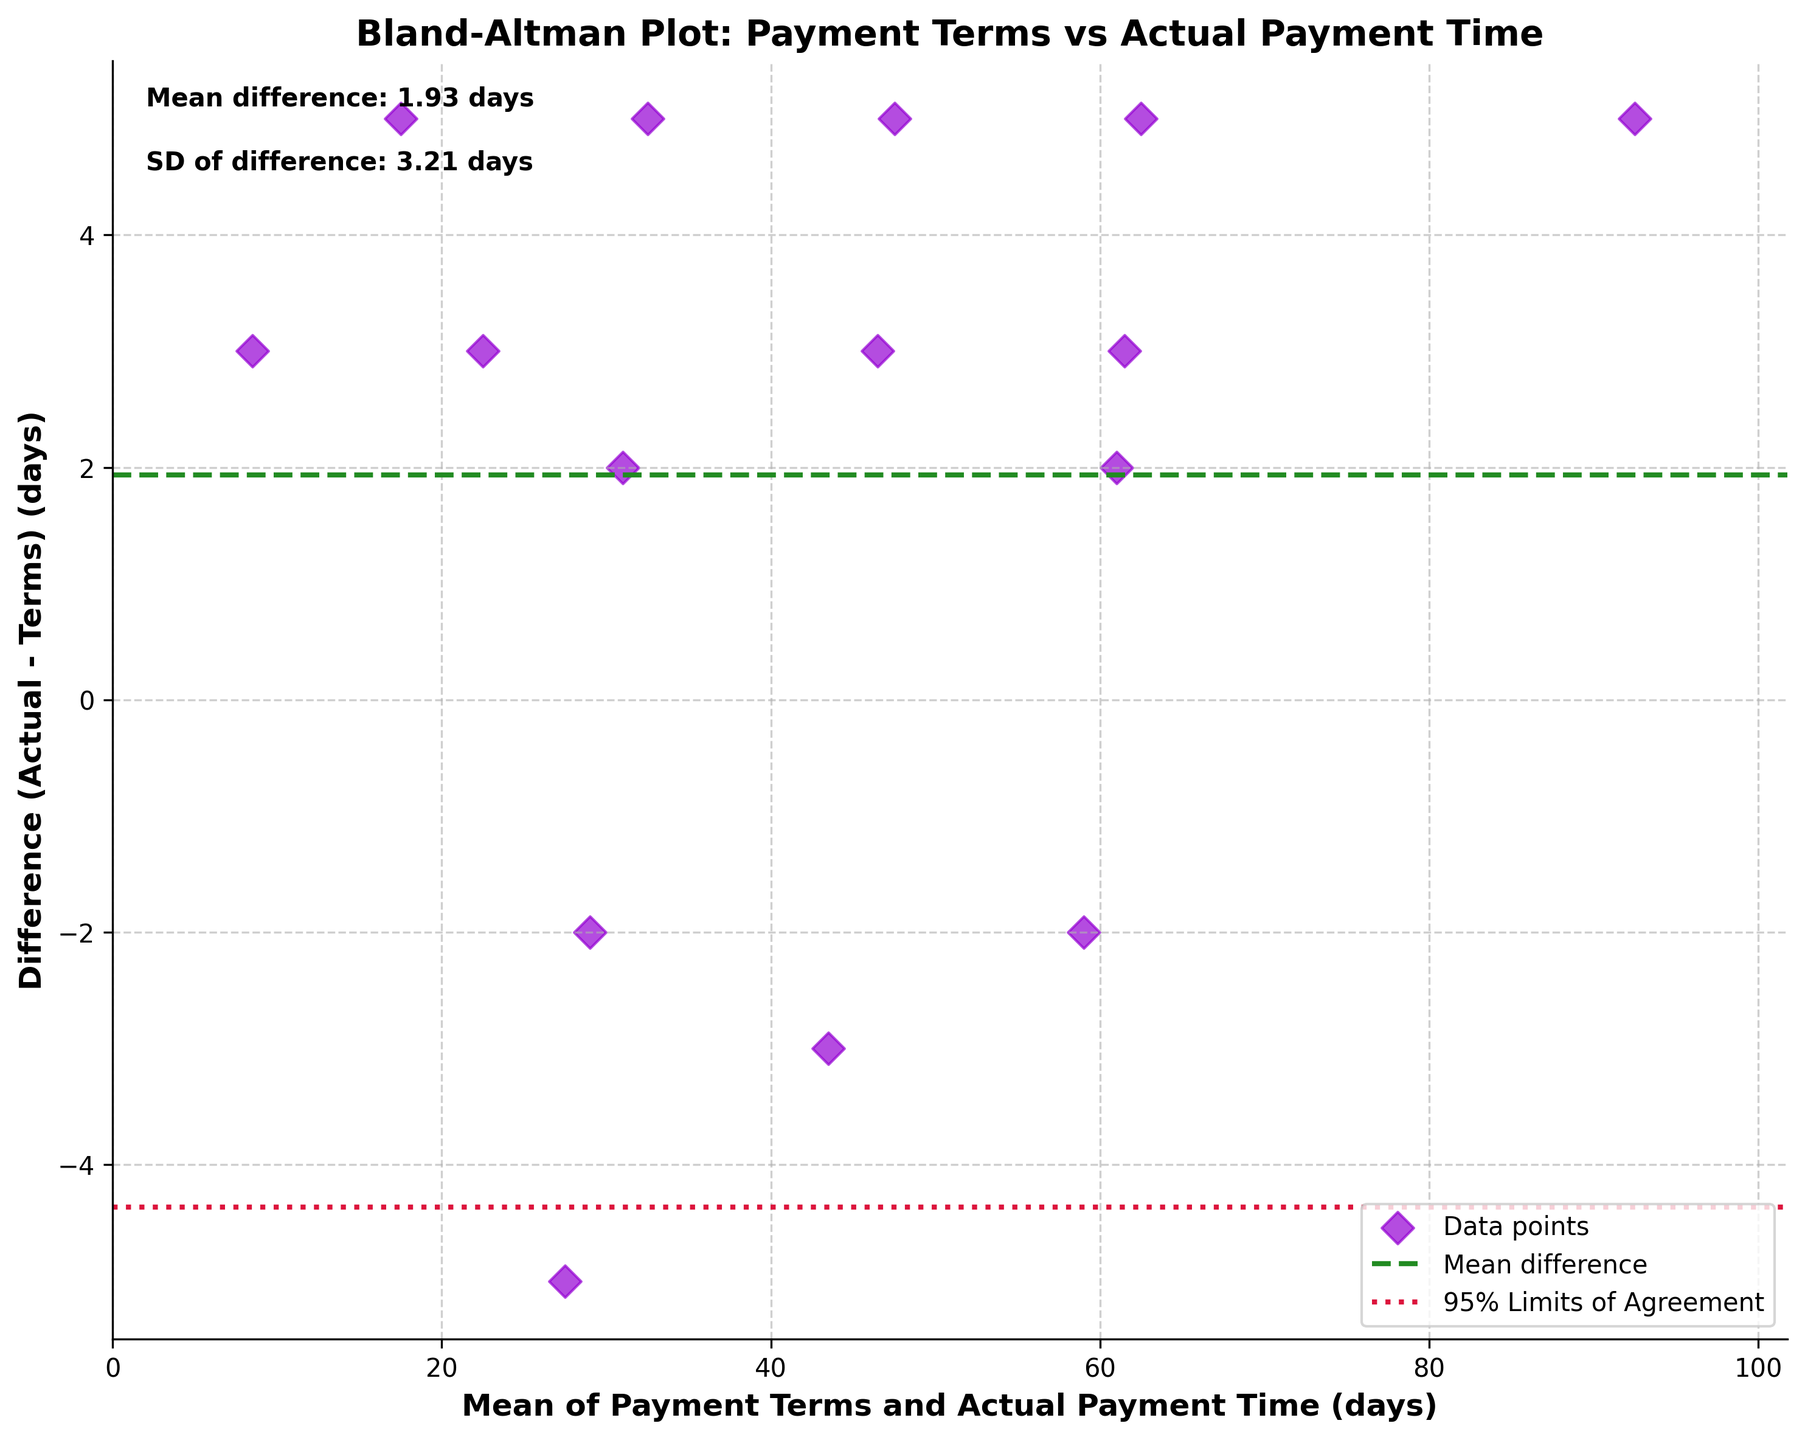What is the title of the plot? The title is written at the top of the figure. It reads "Bland-Altman Plot: Payment Terms vs Actual Payment Time."
Answer: Bland-Altman Plot: Payment Terms vs Actual Payment Time What do the x-axis and y-axis represent? The x-axis label located at the bottom of the figure represents the 'Mean of Payment Terms and Actual Payment Time (days)', and the y-axis label on the left represents the 'Difference (Actual - Terms) (days)'.
Answer: Mean of Payment Terms and Actual Payment Time (days), Difference (Actual - Terms) (days) How many data points are represented in the plot? Each data point is represented by a dark violet diamond marker. Counting them gives 15 data points.
Answer: 15 What are the values for the mean difference, and the upper and lower limits of agreement? The mean difference is annotated as a text on the top left reading 'Mean difference: X days'. It's also represented by a central green dashed line. The upper and lower limits are indicated by crimson dotted lines at +/- 1.96*SD from the mean difference. Summing up these values based on the annotations gives the respective limits and mean.
Answer: Mean difference: X days, Upper limit: Y days, Lower limit: Z days What is the color used to indicate data points? The color used for data points, represented as diamond markers, is dark violet.
Answer: Dark violet Which payment term has the largest difference between actual payment time and terms? The largest positive difference can be identified by the highest diamond marker on the y-axis. Comparing the actual vs. terms, the 'Net 90' term has the highest actual payment time of '95', creating a difference of 5 days.
Answer: Net 90 How many payment terms resulted in customers paying earlier than expected? Points below the zero mark on the y-axis represent earlier payments. A quick count of these points yields the number of such terms.
Answer: 3 Which payment term resulted in the smallest deviation (closest to zero) between actual and expected payment time? The closest point to the zero-line can be observed visually or checked for specific labels near zero on the y-axis. The ’2/10 Net 30’ has a deviation of -2, which is closest to zero in this plot.
Answer: 2/10 Net 30 What is the range of the differences between actual payment time and terms? The y-axis bounds these differences. The highest positive difference is 5, and the lowest (most negative) is -5, leading to a range from -5 to 5 days.
Answer: -5 to 5 days Why are there dotted lines on either side of the mean line? The dotted lines represent the 95% limits of agreement (+/- 1.96 standard deviations from the mean difference). They show the range within which 95% of the differences are expected to lie.
Answer: 95% limits of agreement 